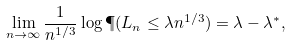<formula> <loc_0><loc_0><loc_500><loc_500>\lim _ { n \to \infty } \frac { 1 } { n ^ { 1 / 3 } } \log \P ( L _ { n } \leq \lambda n ^ { 1 / 3 } ) = \lambda - \lambda ^ { * } ,</formula> 